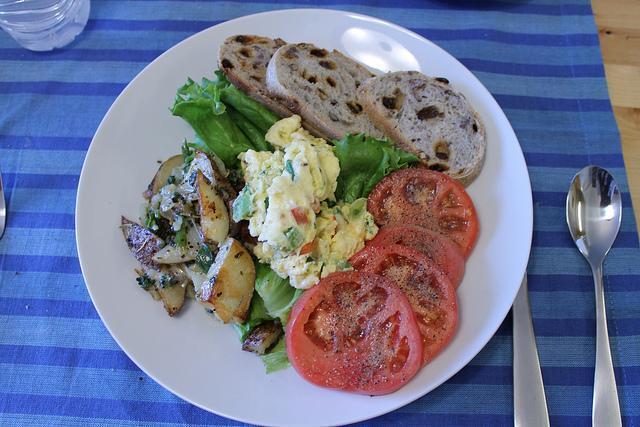How many dining tables are in the photo?
Give a very brief answer. 1. 